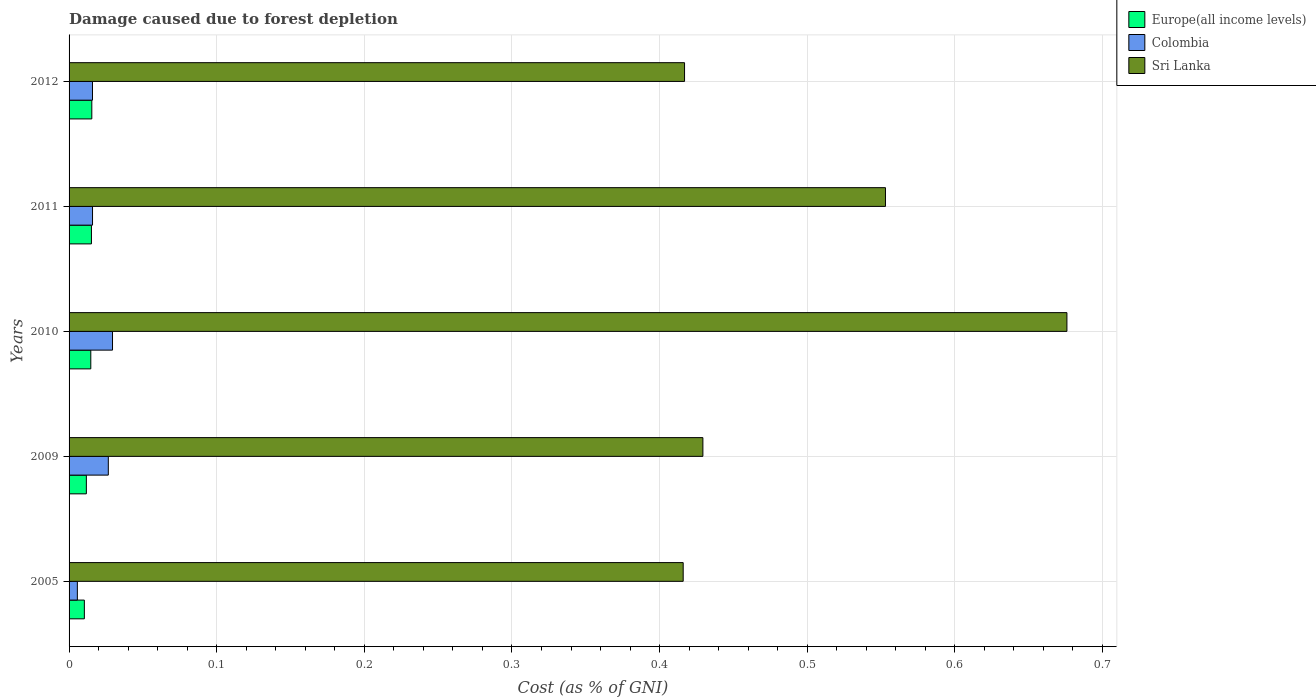How many groups of bars are there?
Provide a short and direct response. 5. Are the number of bars per tick equal to the number of legend labels?
Offer a terse response. Yes. Are the number of bars on each tick of the Y-axis equal?
Ensure brevity in your answer.  Yes. How many bars are there on the 3rd tick from the bottom?
Offer a terse response. 3. What is the label of the 5th group of bars from the top?
Provide a succinct answer. 2005. What is the cost of damage caused due to forest depletion in Colombia in 2010?
Keep it short and to the point. 0.03. Across all years, what is the maximum cost of damage caused due to forest depletion in Europe(all income levels)?
Keep it short and to the point. 0.02. Across all years, what is the minimum cost of damage caused due to forest depletion in Sri Lanka?
Your response must be concise. 0.42. In which year was the cost of damage caused due to forest depletion in Europe(all income levels) maximum?
Provide a short and direct response. 2012. What is the total cost of damage caused due to forest depletion in Sri Lanka in the graph?
Offer a terse response. 2.49. What is the difference between the cost of damage caused due to forest depletion in Sri Lanka in 2005 and that in 2010?
Keep it short and to the point. -0.26. What is the difference between the cost of damage caused due to forest depletion in Sri Lanka in 2009 and the cost of damage caused due to forest depletion in Europe(all income levels) in 2012?
Your answer should be very brief. 0.41. What is the average cost of damage caused due to forest depletion in Europe(all income levels) per year?
Ensure brevity in your answer.  0.01. In the year 2005, what is the difference between the cost of damage caused due to forest depletion in Colombia and cost of damage caused due to forest depletion in Europe(all income levels)?
Make the answer very short. -0. In how many years, is the cost of damage caused due to forest depletion in Colombia greater than 0.44 %?
Offer a terse response. 0. What is the ratio of the cost of damage caused due to forest depletion in Europe(all income levels) in 2011 to that in 2012?
Your answer should be compact. 0.98. What is the difference between the highest and the second highest cost of damage caused due to forest depletion in Sri Lanka?
Make the answer very short. 0.12. What is the difference between the highest and the lowest cost of damage caused due to forest depletion in Sri Lanka?
Give a very brief answer. 0.26. In how many years, is the cost of damage caused due to forest depletion in Europe(all income levels) greater than the average cost of damage caused due to forest depletion in Europe(all income levels) taken over all years?
Give a very brief answer. 3. What does the 3rd bar from the top in 2005 represents?
Give a very brief answer. Europe(all income levels). Is it the case that in every year, the sum of the cost of damage caused due to forest depletion in Europe(all income levels) and cost of damage caused due to forest depletion in Sri Lanka is greater than the cost of damage caused due to forest depletion in Colombia?
Your response must be concise. Yes. Are the values on the major ticks of X-axis written in scientific E-notation?
Offer a very short reply. No. Does the graph contain grids?
Provide a succinct answer. Yes. What is the title of the graph?
Make the answer very short. Damage caused due to forest depletion. What is the label or title of the X-axis?
Your answer should be very brief. Cost (as % of GNI). What is the label or title of the Y-axis?
Offer a very short reply. Years. What is the Cost (as % of GNI) in Europe(all income levels) in 2005?
Keep it short and to the point. 0.01. What is the Cost (as % of GNI) of Colombia in 2005?
Provide a short and direct response. 0.01. What is the Cost (as % of GNI) of Sri Lanka in 2005?
Give a very brief answer. 0.42. What is the Cost (as % of GNI) in Europe(all income levels) in 2009?
Give a very brief answer. 0.01. What is the Cost (as % of GNI) of Colombia in 2009?
Keep it short and to the point. 0.03. What is the Cost (as % of GNI) of Sri Lanka in 2009?
Ensure brevity in your answer.  0.43. What is the Cost (as % of GNI) of Europe(all income levels) in 2010?
Ensure brevity in your answer.  0.01. What is the Cost (as % of GNI) in Colombia in 2010?
Keep it short and to the point. 0.03. What is the Cost (as % of GNI) of Sri Lanka in 2010?
Provide a short and direct response. 0.68. What is the Cost (as % of GNI) of Europe(all income levels) in 2011?
Give a very brief answer. 0.02. What is the Cost (as % of GNI) in Colombia in 2011?
Your answer should be compact. 0.02. What is the Cost (as % of GNI) in Sri Lanka in 2011?
Offer a terse response. 0.55. What is the Cost (as % of GNI) in Europe(all income levels) in 2012?
Provide a succinct answer. 0.02. What is the Cost (as % of GNI) in Colombia in 2012?
Offer a very short reply. 0.02. What is the Cost (as % of GNI) in Sri Lanka in 2012?
Give a very brief answer. 0.42. Across all years, what is the maximum Cost (as % of GNI) of Europe(all income levels)?
Ensure brevity in your answer.  0.02. Across all years, what is the maximum Cost (as % of GNI) in Colombia?
Make the answer very short. 0.03. Across all years, what is the maximum Cost (as % of GNI) in Sri Lanka?
Provide a short and direct response. 0.68. Across all years, what is the minimum Cost (as % of GNI) in Europe(all income levels)?
Make the answer very short. 0.01. Across all years, what is the minimum Cost (as % of GNI) in Colombia?
Offer a very short reply. 0.01. Across all years, what is the minimum Cost (as % of GNI) of Sri Lanka?
Make the answer very short. 0.42. What is the total Cost (as % of GNI) of Europe(all income levels) in the graph?
Offer a terse response. 0.07. What is the total Cost (as % of GNI) in Colombia in the graph?
Offer a terse response. 0.09. What is the total Cost (as % of GNI) in Sri Lanka in the graph?
Ensure brevity in your answer.  2.49. What is the difference between the Cost (as % of GNI) in Europe(all income levels) in 2005 and that in 2009?
Keep it short and to the point. -0. What is the difference between the Cost (as % of GNI) of Colombia in 2005 and that in 2009?
Ensure brevity in your answer.  -0.02. What is the difference between the Cost (as % of GNI) in Sri Lanka in 2005 and that in 2009?
Your answer should be compact. -0.01. What is the difference between the Cost (as % of GNI) of Europe(all income levels) in 2005 and that in 2010?
Your response must be concise. -0. What is the difference between the Cost (as % of GNI) in Colombia in 2005 and that in 2010?
Offer a terse response. -0.02. What is the difference between the Cost (as % of GNI) in Sri Lanka in 2005 and that in 2010?
Provide a succinct answer. -0.26. What is the difference between the Cost (as % of GNI) of Europe(all income levels) in 2005 and that in 2011?
Your response must be concise. -0. What is the difference between the Cost (as % of GNI) in Colombia in 2005 and that in 2011?
Keep it short and to the point. -0.01. What is the difference between the Cost (as % of GNI) of Sri Lanka in 2005 and that in 2011?
Ensure brevity in your answer.  -0.14. What is the difference between the Cost (as % of GNI) of Europe(all income levels) in 2005 and that in 2012?
Provide a succinct answer. -0.01. What is the difference between the Cost (as % of GNI) in Colombia in 2005 and that in 2012?
Ensure brevity in your answer.  -0.01. What is the difference between the Cost (as % of GNI) in Sri Lanka in 2005 and that in 2012?
Make the answer very short. -0. What is the difference between the Cost (as % of GNI) in Europe(all income levels) in 2009 and that in 2010?
Offer a terse response. -0. What is the difference between the Cost (as % of GNI) in Colombia in 2009 and that in 2010?
Offer a terse response. -0. What is the difference between the Cost (as % of GNI) of Sri Lanka in 2009 and that in 2010?
Keep it short and to the point. -0.25. What is the difference between the Cost (as % of GNI) in Europe(all income levels) in 2009 and that in 2011?
Provide a short and direct response. -0. What is the difference between the Cost (as % of GNI) in Colombia in 2009 and that in 2011?
Make the answer very short. 0.01. What is the difference between the Cost (as % of GNI) of Sri Lanka in 2009 and that in 2011?
Your answer should be compact. -0.12. What is the difference between the Cost (as % of GNI) of Europe(all income levels) in 2009 and that in 2012?
Provide a succinct answer. -0. What is the difference between the Cost (as % of GNI) in Colombia in 2009 and that in 2012?
Give a very brief answer. 0.01. What is the difference between the Cost (as % of GNI) in Sri Lanka in 2009 and that in 2012?
Keep it short and to the point. 0.01. What is the difference between the Cost (as % of GNI) in Europe(all income levels) in 2010 and that in 2011?
Provide a succinct answer. -0. What is the difference between the Cost (as % of GNI) in Colombia in 2010 and that in 2011?
Offer a very short reply. 0.01. What is the difference between the Cost (as % of GNI) of Sri Lanka in 2010 and that in 2011?
Ensure brevity in your answer.  0.12. What is the difference between the Cost (as % of GNI) of Europe(all income levels) in 2010 and that in 2012?
Provide a succinct answer. -0. What is the difference between the Cost (as % of GNI) in Colombia in 2010 and that in 2012?
Offer a terse response. 0.01. What is the difference between the Cost (as % of GNI) in Sri Lanka in 2010 and that in 2012?
Offer a terse response. 0.26. What is the difference between the Cost (as % of GNI) of Europe(all income levels) in 2011 and that in 2012?
Offer a very short reply. -0. What is the difference between the Cost (as % of GNI) in Sri Lanka in 2011 and that in 2012?
Provide a short and direct response. 0.14. What is the difference between the Cost (as % of GNI) in Europe(all income levels) in 2005 and the Cost (as % of GNI) in Colombia in 2009?
Ensure brevity in your answer.  -0.02. What is the difference between the Cost (as % of GNI) in Europe(all income levels) in 2005 and the Cost (as % of GNI) in Sri Lanka in 2009?
Keep it short and to the point. -0.42. What is the difference between the Cost (as % of GNI) in Colombia in 2005 and the Cost (as % of GNI) in Sri Lanka in 2009?
Your response must be concise. -0.42. What is the difference between the Cost (as % of GNI) of Europe(all income levels) in 2005 and the Cost (as % of GNI) of Colombia in 2010?
Give a very brief answer. -0.02. What is the difference between the Cost (as % of GNI) of Europe(all income levels) in 2005 and the Cost (as % of GNI) of Sri Lanka in 2010?
Ensure brevity in your answer.  -0.67. What is the difference between the Cost (as % of GNI) of Colombia in 2005 and the Cost (as % of GNI) of Sri Lanka in 2010?
Your answer should be very brief. -0.67. What is the difference between the Cost (as % of GNI) of Europe(all income levels) in 2005 and the Cost (as % of GNI) of Colombia in 2011?
Make the answer very short. -0.01. What is the difference between the Cost (as % of GNI) of Europe(all income levels) in 2005 and the Cost (as % of GNI) of Sri Lanka in 2011?
Offer a terse response. -0.54. What is the difference between the Cost (as % of GNI) in Colombia in 2005 and the Cost (as % of GNI) in Sri Lanka in 2011?
Keep it short and to the point. -0.55. What is the difference between the Cost (as % of GNI) of Europe(all income levels) in 2005 and the Cost (as % of GNI) of Colombia in 2012?
Your answer should be very brief. -0.01. What is the difference between the Cost (as % of GNI) in Europe(all income levels) in 2005 and the Cost (as % of GNI) in Sri Lanka in 2012?
Make the answer very short. -0.41. What is the difference between the Cost (as % of GNI) of Colombia in 2005 and the Cost (as % of GNI) of Sri Lanka in 2012?
Ensure brevity in your answer.  -0.41. What is the difference between the Cost (as % of GNI) in Europe(all income levels) in 2009 and the Cost (as % of GNI) in Colombia in 2010?
Make the answer very short. -0.02. What is the difference between the Cost (as % of GNI) of Europe(all income levels) in 2009 and the Cost (as % of GNI) of Sri Lanka in 2010?
Provide a succinct answer. -0.66. What is the difference between the Cost (as % of GNI) of Colombia in 2009 and the Cost (as % of GNI) of Sri Lanka in 2010?
Provide a short and direct response. -0.65. What is the difference between the Cost (as % of GNI) of Europe(all income levels) in 2009 and the Cost (as % of GNI) of Colombia in 2011?
Your response must be concise. -0. What is the difference between the Cost (as % of GNI) of Europe(all income levels) in 2009 and the Cost (as % of GNI) of Sri Lanka in 2011?
Offer a very short reply. -0.54. What is the difference between the Cost (as % of GNI) of Colombia in 2009 and the Cost (as % of GNI) of Sri Lanka in 2011?
Your response must be concise. -0.53. What is the difference between the Cost (as % of GNI) of Europe(all income levels) in 2009 and the Cost (as % of GNI) of Colombia in 2012?
Your response must be concise. -0. What is the difference between the Cost (as % of GNI) in Europe(all income levels) in 2009 and the Cost (as % of GNI) in Sri Lanka in 2012?
Provide a succinct answer. -0.41. What is the difference between the Cost (as % of GNI) of Colombia in 2009 and the Cost (as % of GNI) of Sri Lanka in 2012?
Your answer should be very brief. -0.39. What is the difference between the Cost (as % of GNI) in Europe(all income levels) in 2010 and the Cost (as % of GNI) in Colombia in 2011?
Keep it short and to the point. -0. What is the difference between the Cost (as % of GNI) in Europe(all income levels) in 2010 and the Cost (as % of GNI) in Sri Lanka in 2011?
Provide a succinct answer. -0.54. What is the difference between the Cost (as % of GNI) in Colombia in 2010 and the Cost (as % of GNI) in Sri Lanka in 2011?
Your answer should be very brief. -0.52. What is the difference between the Cost (as % of GNI) of Europe(all income levels) in 2010 and the Cost (as % of GNI) of Colombia in 2012?
Ensure brevity in your answer.  -0. What is the difference between the Cost (as % of GNI) of Europe(all income levels) in 2010 and the Cost (as % of GNI) of Sri Lanka in 2012?
Give a very brief answer. -0.4. What is the difference between the Cost (as % of GNI) of Colombia in 2010 and the Cost (as % of GNI) of Sri Lanka in 2012?
Your response must be concise. -0.39. What is the difference between the Cost (as % of GNI) of Europe(all income levels) in 2011 and the Cost (as % of GNI) of Colombia in 2012?
Your answer should be very brief. -0. What is the difference between the Cost (as % of GNI) in Europe(all income levels) in 2011 and the Cost (as % of GNI) in Sri Lanka in 2012?
Your response must be concise. -0.4. What is the difference between the Cost (as % of GNI) in Colombia in 2011 and the Cost (as % of GNI) in Sri Lanka in 2012?
Your answer should be very brief. -0.4. What is the average Cost (as % of GNI) in Europe(all income levels) per year?
Your answer should be very brief. 0.01. What is the average Cost (as % of GNI) of Colombia per year?
Your response must be concise. 0.02. What is the average Cost (as % of GNI) of Sri Lanka per year?
Your answer should be very brief. 0.5. In the year 2005, what is the difference between the Cost (as % of GNI) in Europe(all income levels) and Cost (as % of GNI) in Colombia?
Make the answer very short. 0. In the year 2005, what is the difference between the Cost (as % of GNI) in Europe(all income levels) and Cost (as % of GNI) in Sri Lanka?
Your response must be concise. -0.41. In the year 2005, what is the difference between the Cost (as % of GNI) of Colombia and Cost (as % of GNI) of Sri Lanka?
Keep it short and to the point. -0.41. In the year 2009, what is the difference between the Cost (as % of GNI) in Europe(all income levels) and Cost (as % of GNI) in Colombia?
Offer a very short reply. -0.01. In the year 2009, what is the difference between the Cost (as % of GNI) of Europe(all income levels) and Cost (as % of GNI) of Sri Lanka?
Offer a very short reply. -0.42. In the year 2009, what is the difference between the Cost (as % of GNI) in Colombia and Cost (as % of GNI) in Sri Lanka?
Provide a short and direct response. -0.4. In the year 2010, what is the difference between the Cost (as % of GNI) of Europe(all income levels) and Cost (as % of GNI) of Colombia?
Provide a short and direct response. -0.01. In the year 2010, what is the difference between the Cost (as % of GNI) of Europe(all income levels) and Cost (as % of GNI) of Sri Lanka?
Your response must be concise. -0.66. In the year 2010, what is the difference between the Cost (as % of GNI) in Colombia and Cost (as % of GNI) in Sri Lanka?
Offer a terse response. -0.65. In the year 2011, what is the difference between the Cost (as % of GNI) in Europe(all income levels) and Cost (as % of GNI) in Colombia?
Ensure brevity in your answer.  -0. In the year 2011, what is the difference between the Cost (as % of GNI) in Europe(all income levels) and Cost (as % of GNI) in Sri Lanka?
Make the answer very short. -0.54. In the year 2011, what is the difference between the Cost (as % of GNI) in Colombia and Cost (as % of GNI) in Sri Lanka?
Provide a short and direct response. -0.54. In the year 2012, what is the difference between the Cost (as % of GNI) in Europe(all income levels) and Cost (as % of GNI) in Colombia?
Make the answer very short. -0. In the year 2012, what is the difference between the Cost (as % of GNI) of Europe(all income levels) and Cost (as % of GNI) of Sri Lanka?
Your answer should be very brief. -0.4. In the year 2012, what is the difference between the Cost (as % of GNI) of Colombia and Cost (as % of GNI) of Sri Lanka?
Give a very brief answer. -0.4. What is the ratio of the Cost (as % of GNI) of Europe(all income levels) in 2005 to that in 2009?
Make the answer very short. 0.88. What is the ratio of the Cost (as % of GNI) of Colombia in 2005 to that in 2009?
Keep it short and to the point. 0.21. What is the ratio of the Cost (as % of GNI) in Sri Lanka in 2005 to that in 2009?
Keep it short and to the point. 0.97. What is the ratio of the Cost (as % of GNI) of Europe(all income levels) in 2005 to that in 2010?
Offer a terse response. 0.7. What is the ratio of the Cost (as % of GNI) of Colombia in 2005 to that in 2010?
Offer a very short reply. 0.19. What is the ratio of the Cost (as % of GNI) of Sri Lanka in 2005 to that in 2010?
Provide a succinct answer. 0.62. What is the ratio of the Cost (as % of GNI) of Europe(all income levels) in 2005 to that in 2011?
Make the answer very short. 0.68. What is the ratio of the Cost (as % of GNI) in Colombia in 2005 to that in 2011?
Ensure brevity in your answer.  0.35. What is the ratio of the Cost (as % of GNI) in Sri Lanka in 2005 to that in 2011?
Make the answer very short. 0.75. What is the ratio of the Cost (as % of GNI) of Europe(all income levels) in 2005 to that in 2012?
Ensure brevity in your answer.  0.67. What is the ratio of the Cost (as % of GNI) of Colombia in 2005 to that in 2012?
Your response must be concise. 0.35. What is the ratio of the Cost (as % of GNI) of Sri Lanka in 2005 to that in 2012?
Your response must be concise. 1. What is the ratio of the Cost (as % of GNI) of Europe(all income levels) in 2009 to that in 2010?
Ensure brevity in your answer.  0.8. What is the ratio of the Cost (as % of GNI) in Colombia in 2009 to that in 2010?
Provide a short and direct response. 0.9. What is the ratio of the Cost (as % of GNI) of Sri Lanka in 2009 to that in 2010?
Offer a very short reply. 0.64. What is the ratio of the Cost (as % of GNI) in Europe(all income levels) in 2009 to that in 2011?
Provide a short and direct response. 0.77. What is the ratio of the Cost (as % of GNI) of Colombia in 2009 to that in 2011?
Your response must be concise. 1.67. What is the ratio of the Cost (as % of GNI) in Sri Lanka in 2009 to that in 2011?
Make the answer very short. 0.78. What is the ratio of the Cost (as % of GNI) of Europe(all income levels) in 2009 to that in 2012?
Keep it short and to the point. 0.76. What is the ratio of the Cost (as % of GNI) of Colombia in 2009 to that in 2012?
Offer a terse response. 1.68. What is the ratio of the Cost (as % of GNI) in Sri Lanka in 2009 to that in 2012?
Your answer should be very brief. 1.03. What is the ratio of the Cost (as % of GNI) of Europe(all income levels) in 2010 to that in 2011?
Give a very brief answer. 0.97. What is the ratio of the Cost (as % of GNI) of Colombia in 2010 to that in 2011?
Your answer should be compact. 1.85. What is the ratio of the Cost (as % of GNI) in Sri Lanka in 2010 to that in 2011?
Provide a short and direct response. 1.22. What is the ratio of the Cost (as % of GNI) of Europe(all income levels) in 2010 to that in 2012?
Offer a terse response. 0.96. What is the ratio of the Cost (as % of GNI) of Colombia in 2010 to that in 2012?
Provide a short and direct response. 1.86. What is the ratio of the Cost (as % of GNI) in Sri Lanka in 2010 to that in 2012?
Your answer should be compact. 1.62. What is the ratio of the Cost (as % of GNI) of Europe(all income levels) in 2011 to that in 2012?
Offer a terse response. 0.98. What is the ratio of the Cost (as % of GNI) in Sri Lanka in 2011 to that in 2012?
Offer a very short reply. 1.33. What is the difference between the highest and the second highest Cost (as % of GNI) in Colombia?
Provide a short and direct response. 0. What is the difference between the highest and the second highest Cost (as % of GNI) in Sri Lanka?
Make the answer very short. 0.12. What is the difference between the highest and the lowest Cost (as % of GNI) in Europe(all income levels)?
Keep it short and to the point. 0.01. What is the difference between the highest and the lowest Cost (as % of GNI) in Colombia?
Provide a succinct answer. 0.02. What is the difference between the highest and the lowest Cost (as % of GNI) of Sri Lanka?
Provide a short and direct response. 0.26. 